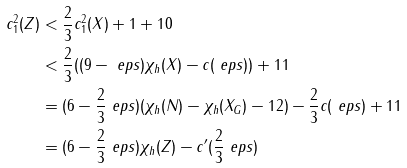<formula> <loc_0><loc_0><loc_500><loc_500>c _ { 1 } ^ { 2 } ( Z ) & < \frac { 2 } { 3 } c _ { 1 } ^ { 2 } ( X ) + 1 + 1 0 \\ & < \frac { 2 } { 3 } ( ( 9 - \ e p s ) \chi _ { h } ( X ) - c ( \ e p s ) ) + 1 1 \\ & = ( 6 - \frac { 2 } { 3 } \ e p s ) ( \chi _ { h } ( N ) - \chi _ { h } ( X _ { G } ) - 1 2 ) - \frac { 2 } { 3 } c ( \ e p s ) + 1 1 \\ & = ( 6 - \frac { 2 } { 3 } \ e p s ) \chi _ { h } ( Z ) - c ^ { \prime } ( \frac { 2 } { 3 } \ e p s )</formula> 